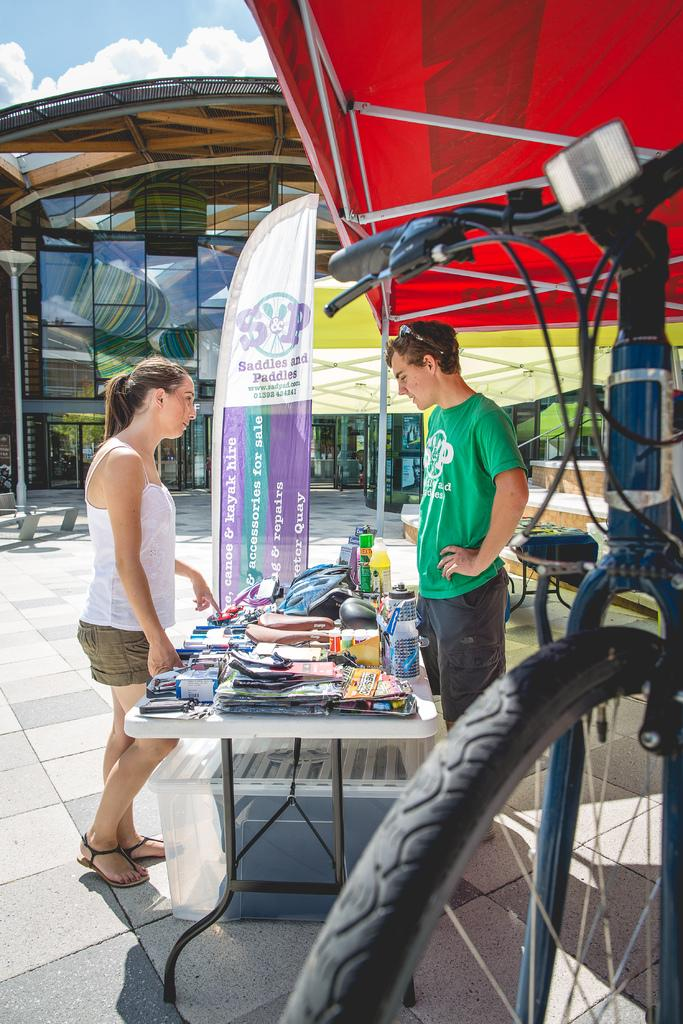How many people are in the image? There are two persons standing in the image. What is present on the table in the image? There is a book and a bag on the table in the image. What can be seen in the background of the image? The background of the image includes clouds, sky, and a tent. What type of skirt is the queen wearing in the image? There is no queen or skirt present in the image. How many trees are visible in the background of the image? There are no trees visible in the background of the image; only clouds, sky, and a tent can be seen. 